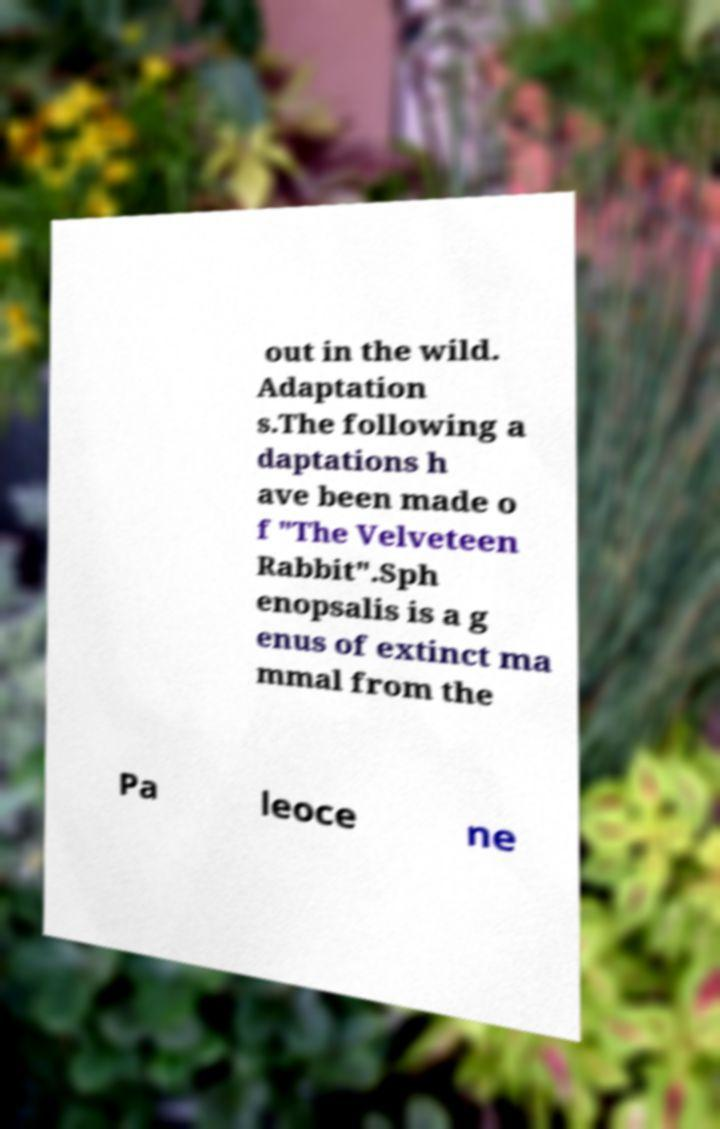What messages or text are displayed in this image? I need them in a readable, typed format. out in the wild. Adaptation s.The following a daptations h ave been made o f "The Velveteen Rabbit".Sph enopsalis is a g enus of extinct ma mmal from the Pa leoce ne 